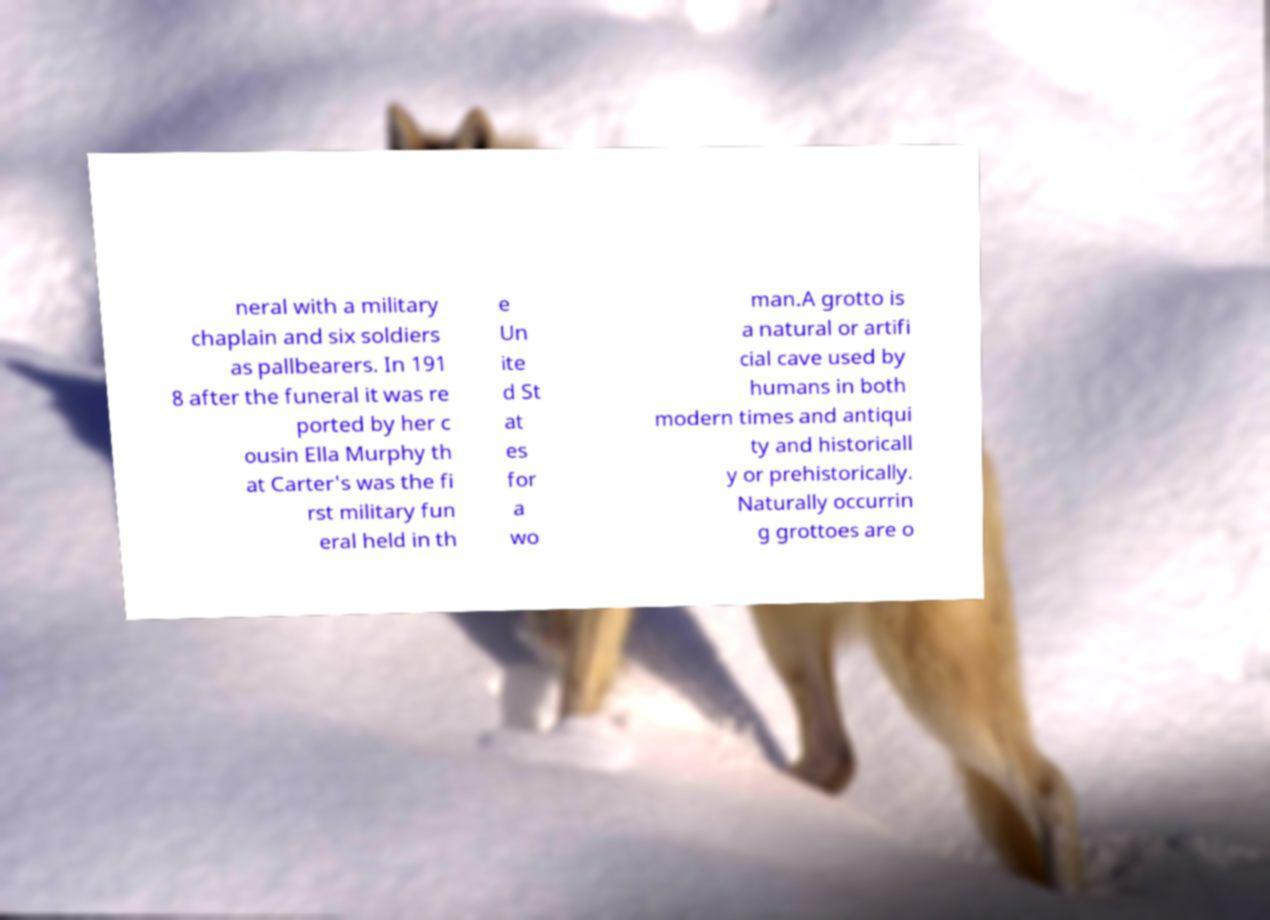I need the written content from this picture converted into text. Can you do that? neral with a military chaplain and six soldiers as pallbearers. In 191 8 after the funeral it was re ported by her c ousin Ella Murphy th at Carter's was the fi rst military fun eral held in th e Un ite d St at es for a wo man.A grotto is a natural or artifi cial cave used by humans in both modern times and antiqui ty and historicall y or prehistorically. Naturally occurrin g grottoes are o 